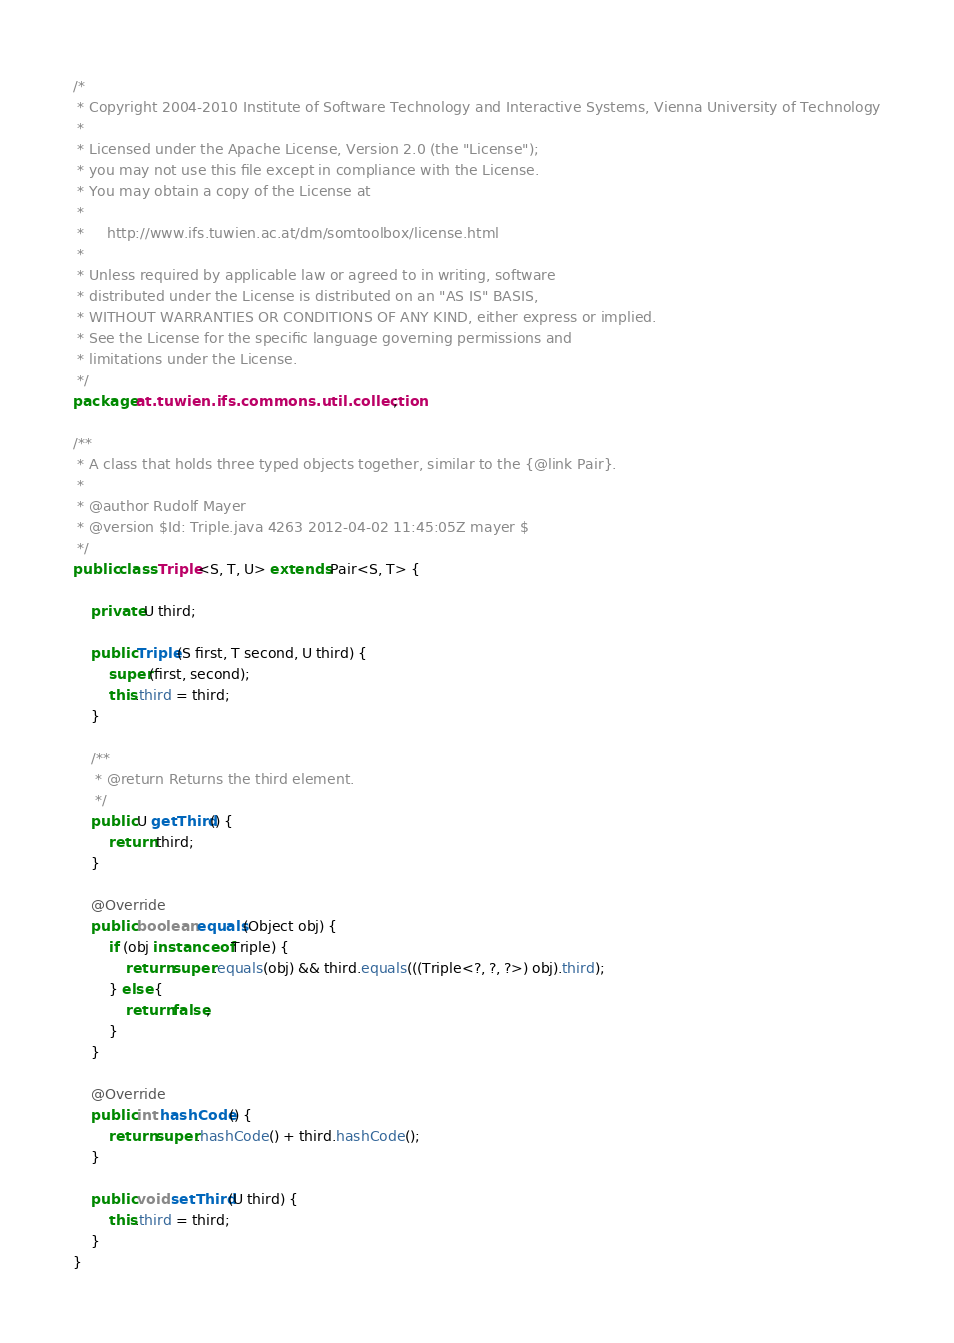Convert code to text. <code><loc_0><loc_0><loc_500><loc_500><_Java_>/*
 * Copyright 2004-2010 Institute of Software Technology and Interactive Systems, Vienna University of Technology
 *
 * Licensed under the Apache License, Version 2.0 (the "License");
 * you may not use this file except in compliance with the License.
 * You may obtain a copy of the License at
 *
 *     http://www.ifs.tuwien.ac.at/dm/somtoolbox/license.html
 *
 * Unless required by applicable law or agreed to in writing, software
 * distributed under the License is distributed on an "AS IS" BASIS,
 * WITHOUT WARRANTIES OR CONDITIONS OF ANY KIND, either express or implied.
 * See the License for the specific language governing permissions and
 * limitations under the License.
 */
package at.tuwien.ifs.commons.util.collection;

/**
 * A class that holds three typed objects together, similar to the {@link Pair}.
 * 
 * @author Rudolf Mayer
 * @version $Id: Triple.java 4263 2012-04-02 11:45:05Z mayer $
 */
public class Triple<S, T, U> extends Pair<S, T> {

    private U third;

    public Triple(S first, T second, U third) {
        super(first, second);
        this.third = third;
    }

    /**
     * @return Returns the third element.
     */
    public U getThird() {
        return third;
    }

    @Override
    public boolean equals(Object obj) {
        if (obj instanceof Triple) {
            return super.equals(obj) && third.equals(((Triple<?, ?, ?>) obj).third);
        } else {
            return false;
        }
    }

    @Override
    public int hashCode() {
        return super.hashCode() + third.hashCode();
    }

    public void setThird(U third) {
        this.third = third;
    }
}
</code> 